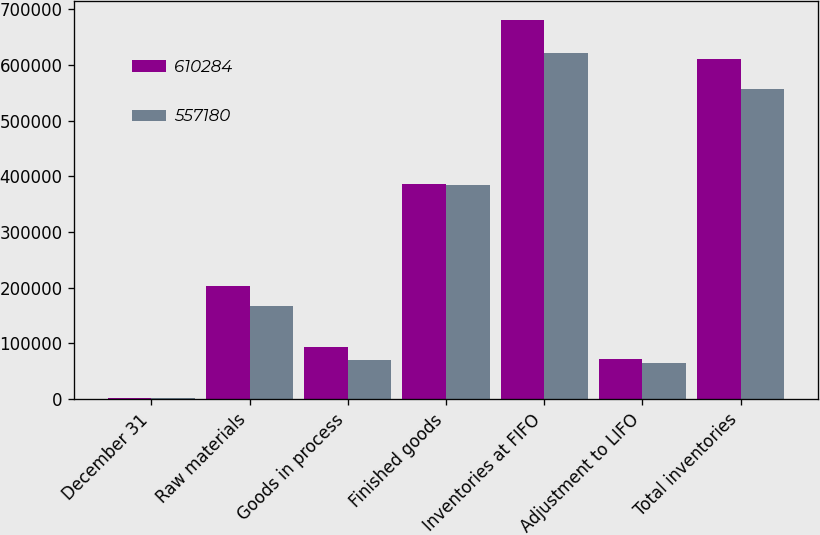Convert chart. <chart><loc_0><loc_0><loc_500><loc_500><stacked_bar_chart><ecel><fcel>December 31<fcel>Raw materials<fcel>Goods in process<fcel>Finished goods<fcel>Inventories at FIFO<fcel>Adjustment to LIFO<fcel>Total inventories<nl><fcel>610284<fcel>2005<fcel>202826<fcel>92923<fcel>385798<fcel>681547<fcel>71263<fcel>610284<nl><fcel>557180<fcel>2004<fcel>166813<fcel>70440<fcel>384094<fcel>621347<fcel>64167<fcel>557180<nl></chart> 